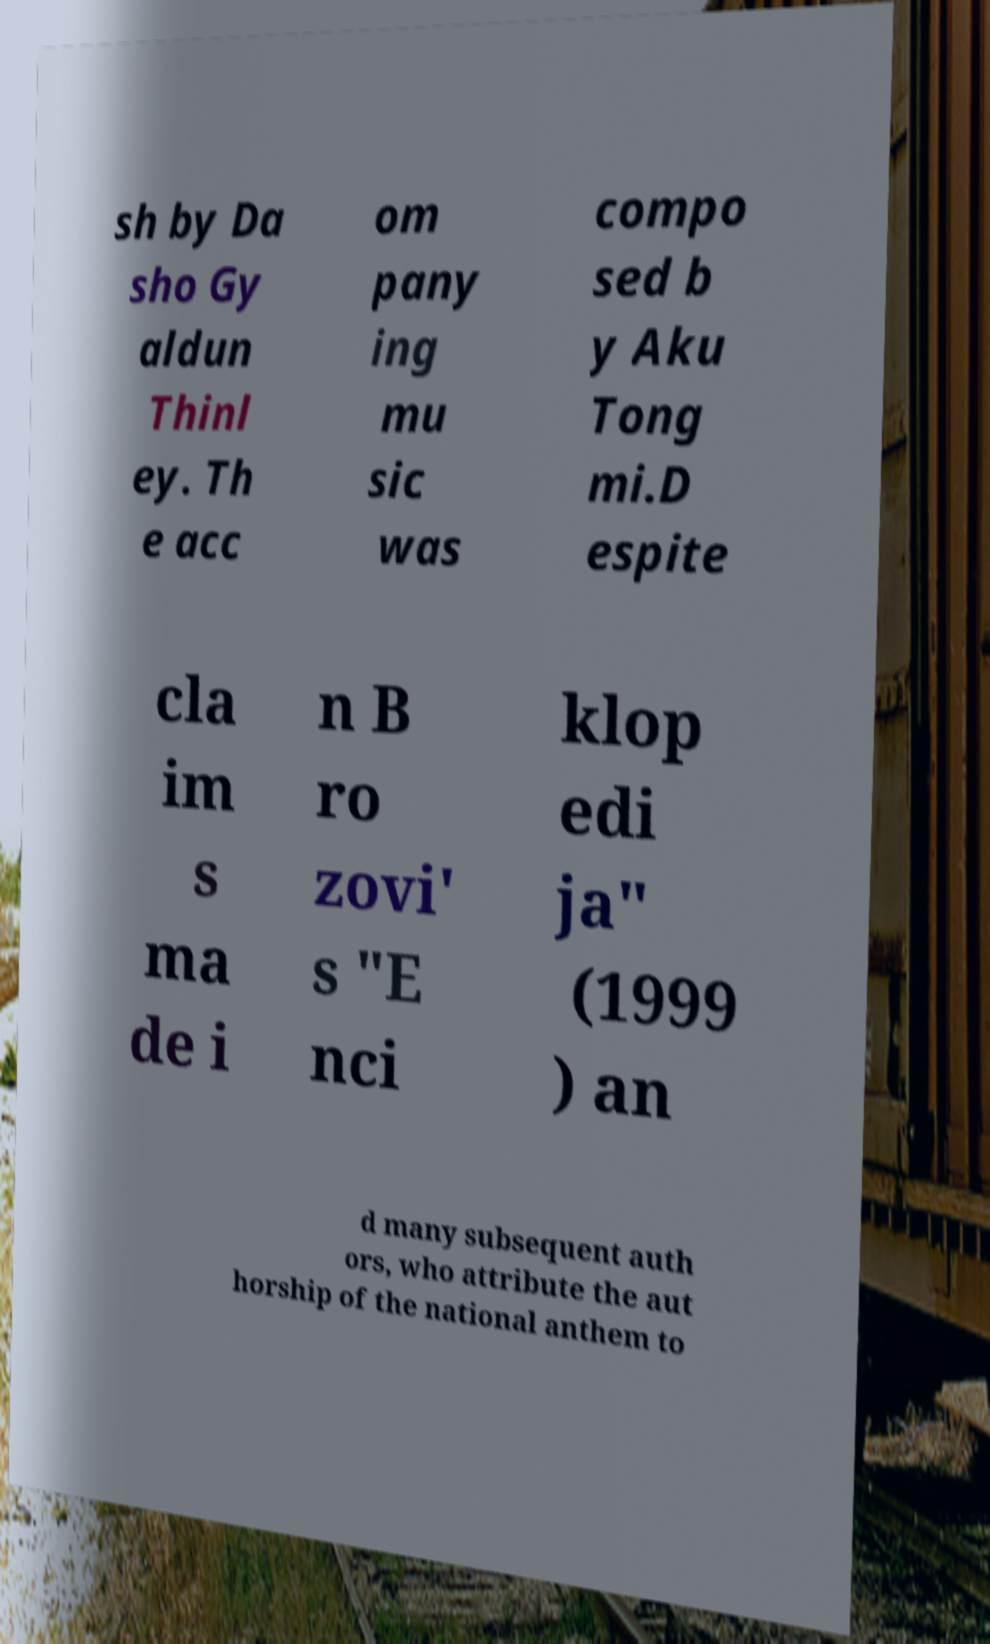Could you extract and type out the text from this image? sh by Da sho Gy aldun Thinl ey. Th e acc om pany ing mu sic was compo sed b y Aku Tong mi.D espite cla im s ma de i n B ro zovi' s "E nci klop edi ja" (1999 ) an d many subsequent auth ors, who attribute the aut horship of the national anthem to 